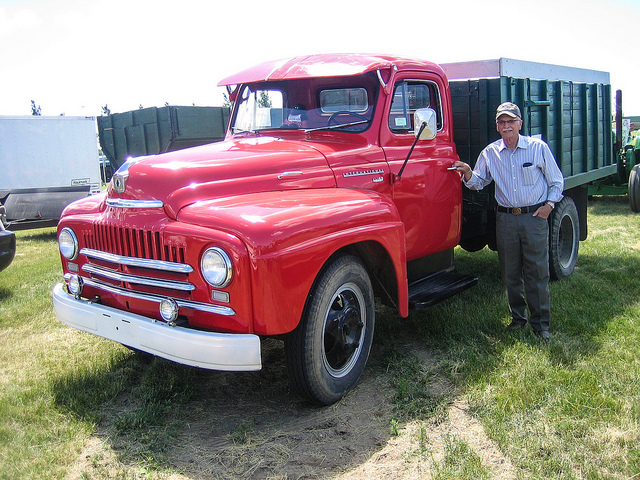<image>What is written on the back of the truck? I do not know what is written on the back of the truck. It could be a plate number or nothing at all. What is written on the back of the truck? I don't know what is written on the back of the truck. It can be seen 'plate', 'america', 'international', or 'license plate numbers'. 